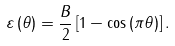Convert formula to latex. <formula><loc_0><loc_0><loc_500><loc_500>\varepsilon \left ( \theta \right ) = \frac { B } { 2 } \left [ 1 - \cos \left ( \pi \theta \right ) \right ] .</formula> 